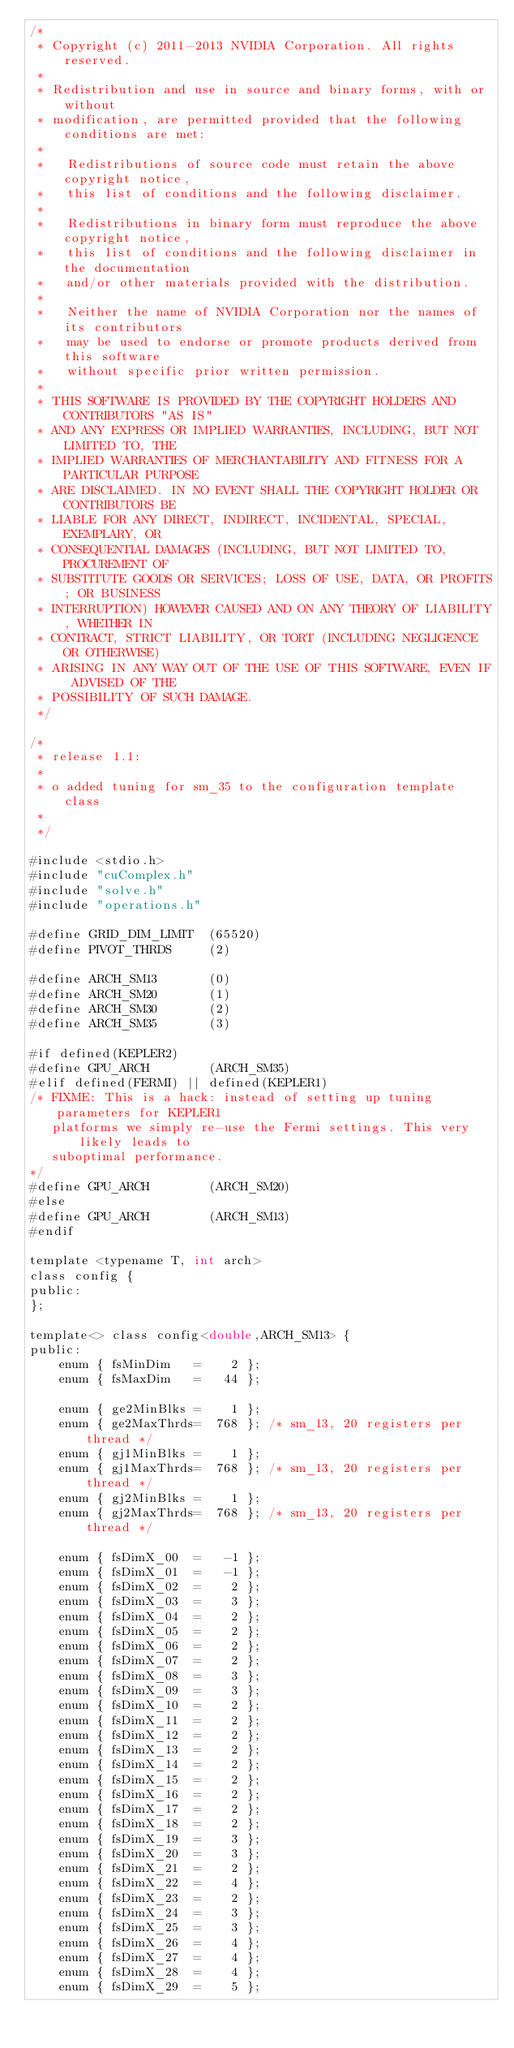Convert code to text. <code><loc_0><loc_0><loc_500><loc_500><_Cuda_>/*
 * Copyright (c) 2011-2013 NVIDIA Corporation. All rights reserved.
 *
 * Redistribution and use in source and binary forms, with or without 
 * modification, are permitted provided that the following conditions are met:
 *
 *   Redistributions of source code must retain the above copyright notice, 
 *   this list of conditions and the following disclaimer.
 *
 *   Redistributions in binary form must reproduce the above copyright notice,
 *   this list of conditions and the following disclaimer in the documentation
 *   and/or other materials provided with the distribution.
 *
 *   Neither the name of NVIDIA Corporation nor the names of its contributors
 *   may be used to endorse or promote products derived from this software 
 *   without specific prior written permission.
 *
 * THIS SOFTWARE IS PROVIDED BY THE COPYRIGHT HOLDERS AND CONTRIBUTORS "AS IS"
 * AND ANY EXPRESS OR IMPLIED WARRANTIES, INCLUDING, BUT NOT LIMITED TO, THE 
 * IMPLIED WARRANTIES OF MERCHANTABILITY AND FITNESS FOR A PARTICULAR PURPOSE 
 * ARE DISCLAIMED. IN NO EVENT SHALL THE COPYRIGHT HOLDER OR CONTRIBUTORS BE 
 * LIABLE FOR ANY DIRECT, INDIRECT, INCIDENTAL, SPECIAL, EXEMPLARY, OR 
 * CONSEQUENTIAL DAMAGES (INCLUDING, BUT NOT LIMITED TO, PROCUREMENT OF 
 * SUBSTITUTE GOODS OR SERVICES; LOSS OF USE, DATA, OR PROFITS; OR BUSINESS 
 * INTERRUPTION) HOWEVER CAUSED AND ON ANY THEORY OF LIABILITY, WHETHER IN 
 * CONTRACT, STRICT LIABILITY, OR TORT (INCLUDING NEGLIGENCE OR OTHERWISE) 
 * ARISING IN ANY WAY OUT OF THE USE OF THIS SOFTWARE, EVEN IF ADVISED OF THE
 * POSSIBILITY OF SUCH DAMAGE.
 */

/*
 * release 1.1:
 *
 * o added tuning for sm_35 to the configuration template class
 *
 */

#include <stdio.h>
#include "cuComplex.h"
#include "solve.h"
#include "operations.h"

#define GRID_DIM_LIMIT  (65520)
#define PIVOT_THRDS     (2)

#define ARCH_SM13       (0)
#define ARCH_SM20       (1)
#define ARCH_SM30       (2)
#define ARCH_SM35       (3)

#if defined(KEPLER2)
#define GPU_ARCH        (ARCH_SM35)
#elif defined(FERMI) || defined(KEPLER1)
/* FIXME: This is a hack: instead of setting up tuning parameters for KEPLER1 
   platforms we simply re-use the Fermi settings. This very likely leads to 
   suboptimal performance.
*/
#define GPU_ARCH        (ARCH_SM20)
#else 
#define GPU_ARCH        (ARCH_SM13)
#endif

template <typename T, int arch>
class config {
public:
};

template<> class config<double,ARCH_SM13> {
public:
    enum { fsMinDim   =    2 };
    enum { fsMaxDim   =   44 };

    enum { ge2MinBlks =    1 };
    enum { ge2MaxThrds=  768 }; /* sm_13, 20 registers per thread */
    enum { gj1MinBlks =    1 };
    enum { gj1MaxThrds=  768 }; /* sm_13, 20 registers per thread */
    enum { gj2MinBlks =    1 };
    enum { gj2MaxThrds=  768 }; /* sm_13, 20 registers per thread */

    enum { fsDimX_00  =   -1 };
    enum { fsDimX_01  =   -1 };
    enum { fsDimX_02  =    2 };
    enum { fsDimX_03  =    3 };
    enum { fsDimX_04  =    2 };
    enum { fsDimX_05  =    2 };
    enum { fsDimX_06  =    2 };
    enum { fsDimX_07  =    2 };
    enum { fsDimX_08  =    3 };
    enum { fsDimX_09  =    3 };
    enum { fsDimX_10  =    2 };
    enum { fsDimX_11  =    2 };
    enum { fsDimX_12  =    2 };
    enum { fsDimX_13  =    2 };
    enum { fsDimX_14  =    2 };
    enum { fsDimX_15  =    2 };
    enum { fsDimX_16  =    2 };
    enum { fsDimX_17  =    2 };
    enum { fsDimX_18  =    2 };
    enum { fsDimX_19  =    3 };
    enum { fsDimX_20  =    3 };
    enum { fsDimX_21  =    2 };
    enum { fsDimX_22  =    4 };
    enum { fsDimX_23  =    2 };
    enum { fsDimX_24  =    3 };
    enum { fsDimX_25  =    3 };
    enum { fsDimX_26  =    4 };
    enum { fsDimX_27  =    4 };
    enum { fsDimX_28  =    4 };
    enum { fsDimX_29  =    5 };</code> 